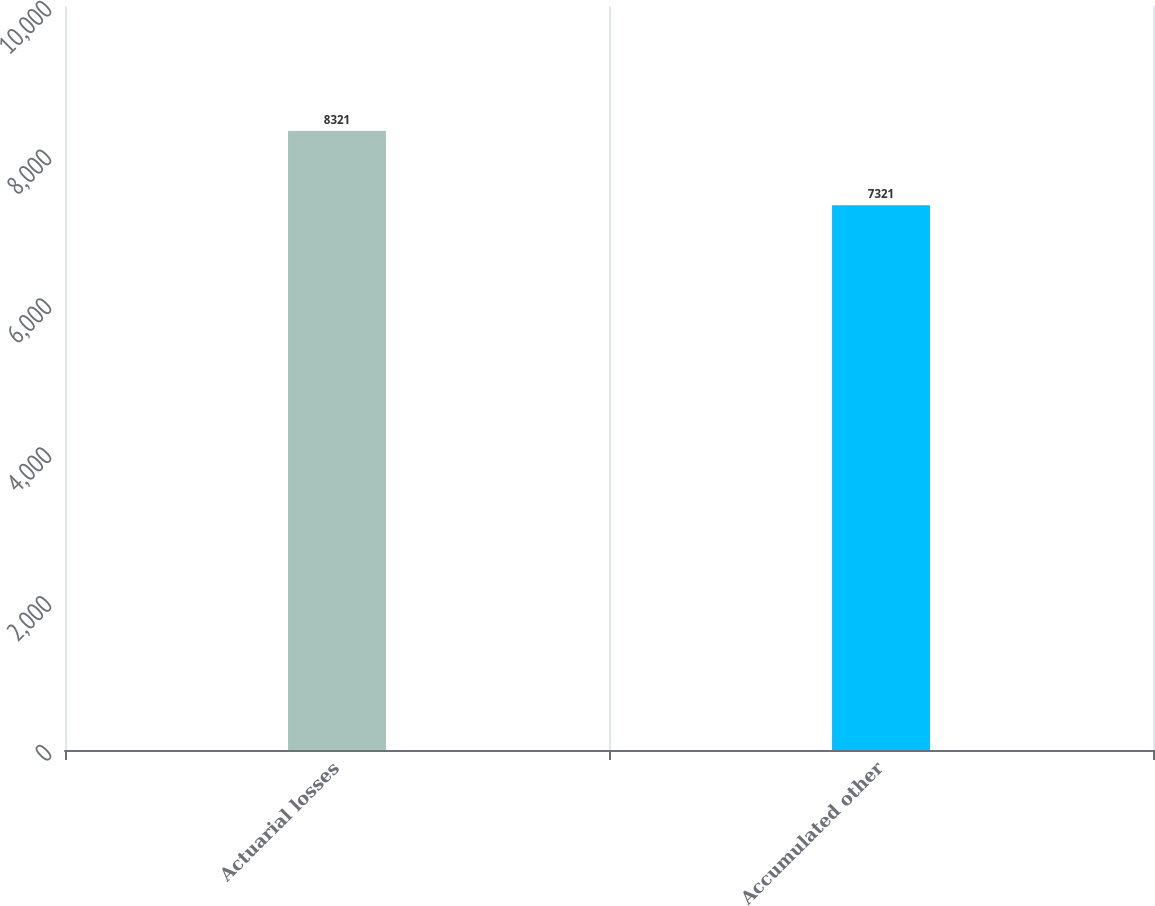Convert chart. <chart><loc_0><loc_0><loc_500><loc_500><bar_chart><fcel>Actuarial losses<fcel>Accumulated other<nl><fcel>8321<fcel>7321<nl></chart> 